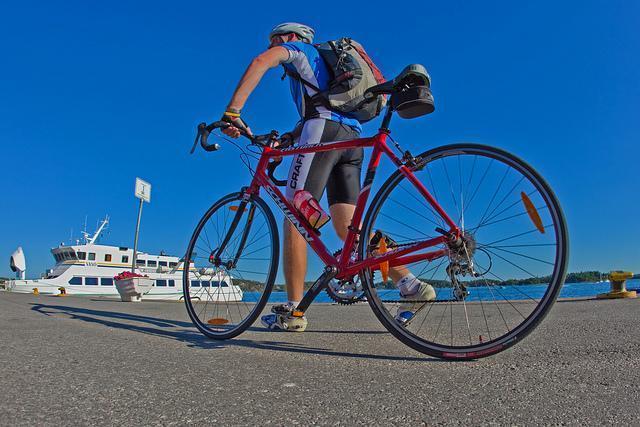Does the description: "The boat is facing away from the bicycle." accurately reflect the image?
Answer yes or no. Yes. Is the statement "The boat is behind the bicycle." accurate regarding the image?
Answer yes or no. Yes. 